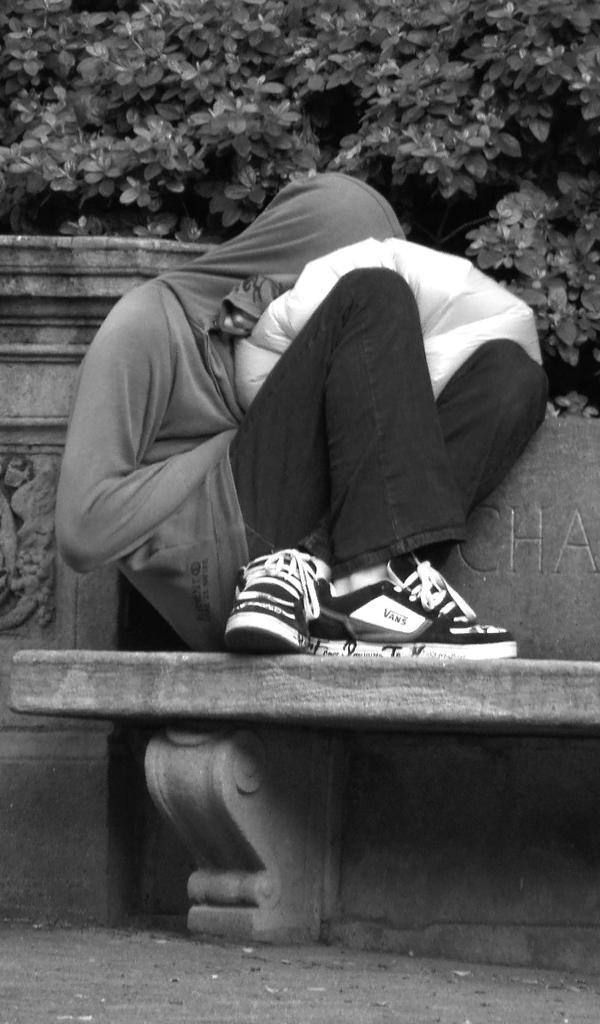Could you give a brief overview of what you see in this image? In this picture we can see a woman who is wearing hoodie, trouser and shoe. He is holding this white color cloth. He is sitting on the bench. On the top we can see tree. On the left we can see statue. 